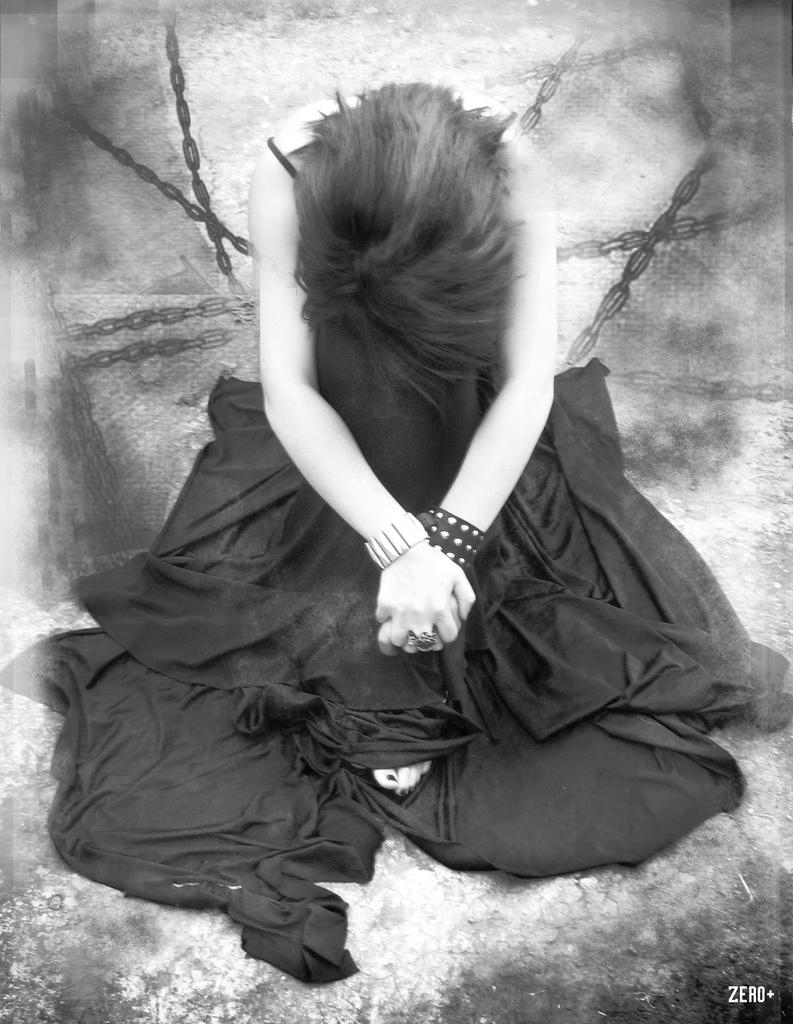Who is the main subject in the image? There is a woman in the image. What is the woman wearing? The woman is wearing a black dress. What is the woman's position in the image? The woman is sitting on the ground. What objects can be seen behind the woman? There are chains present behind the woman. What channel is the crow flying through in the image? There is no crow present in the image, and therefore no channel for it to fly through. Is the woman in the image floating in space? No, the woman is sitting on the ground, not floating in space. 